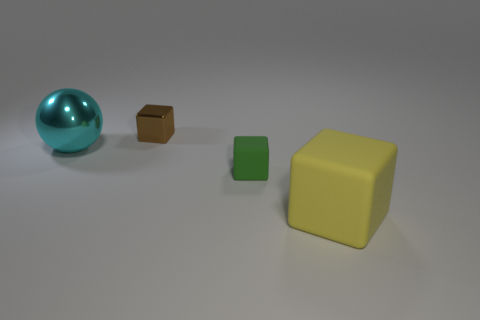Do the green rubber thing and the object to the left of the metal cube have the same size?
Provide a succinct answer. No. There is a small object that is in front of the cube that is behind the matte thing behind the large rubber cube; what is its material?
Ensure brevity in your answer.  Rubber. What number of things are either small gray cylinders or metal objects?
Make the answer very short. 2. Do the rubber object behind the big matte object and the big object to the right of the cyan shiny object have the same color?
Your answer should be very brief. No. What is the shape of the other metallic object that is the same size as the yellow object?
Your answer should be compact. Sphere. How many things are small objects left of the tiny green matte thing or objects on the right side of the shiny cube?
Give a very brief answer. 3. Are there fewer large cyan shiny balls than purple balls?
Your answer should be compact. No. What is the material of the ball that is the same size as the yellow rubber block?
Your answer should be compact. Metal. There is a metal thing that is in front of the brown metallic thing; is its size the same as the thing that is behind the big cyan sphere?
Ensure brevity in your answer.  No. Are there any large objects made of the same material as the brown block?
Your response must be concise. Yes. 